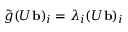<formula> <loc_0><loc_0><loc_500><loc_500>\tilde { g } ( U { b } ) _ { i } = \lambda _ { i } ( U { b } ) _ { i }</formula> 